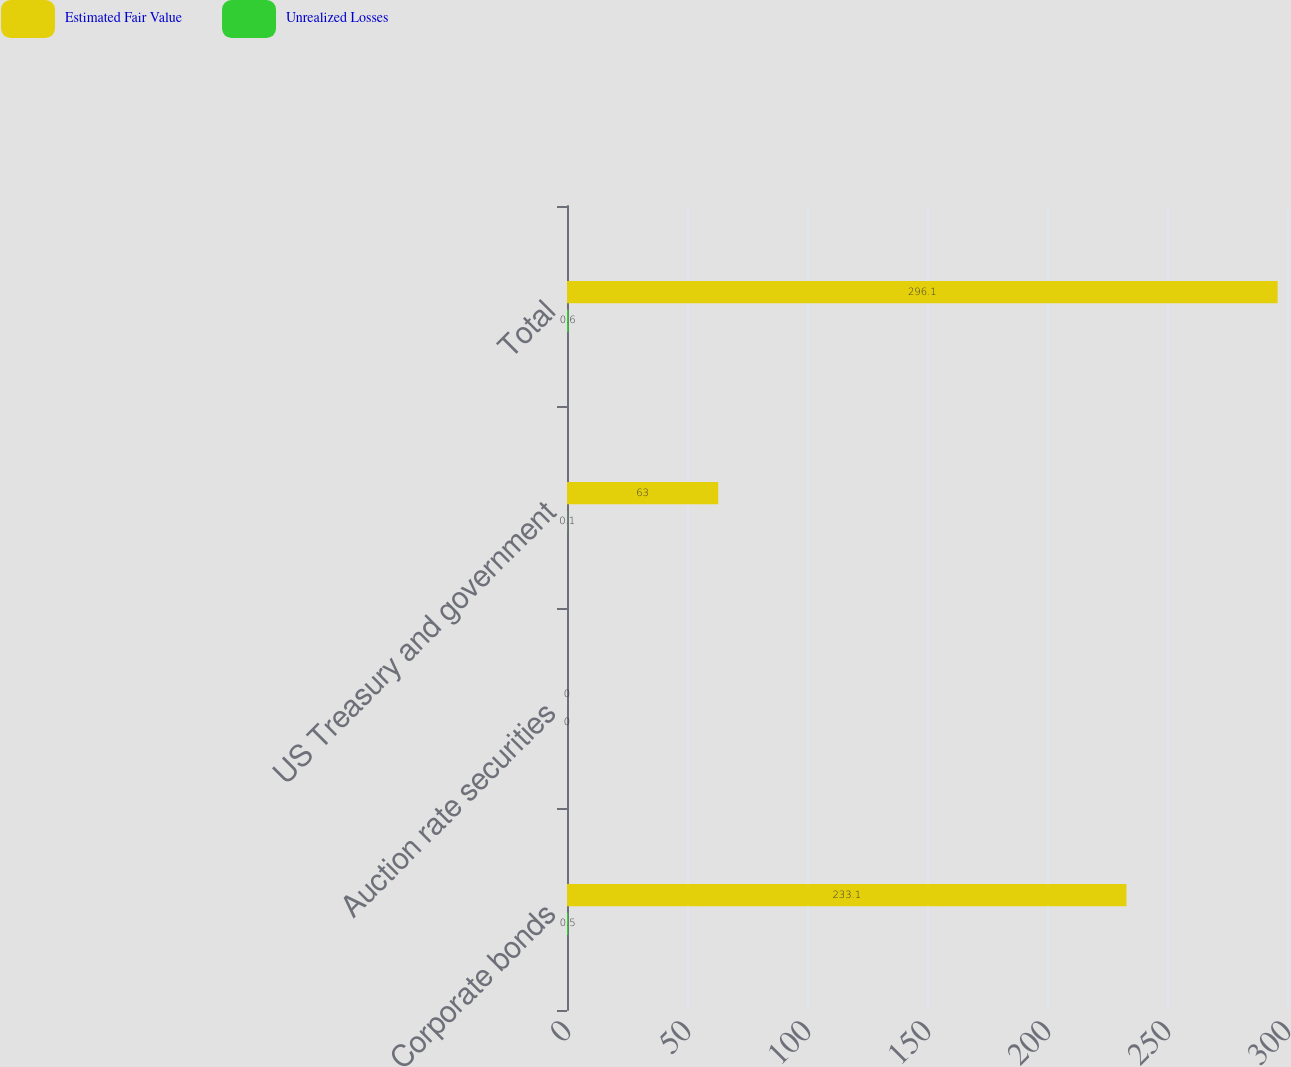Convert chart. <chart><loc_0><loc_0><loc_500><loc_500><stacked_bar_chart><ecel><fcel>Corporate bonds<fcel>Auction rate securities<fcel>US Treasury and government<fcel>Total<nl><fcel>Estimated Fair Value<fcel>233.1<fcel>0<fcel>63<fcel>296.1<nl><fcel>Unrealized Losses<fcel>0.5<fcel>0<fcel>0.1<fcel>0.6<nl></chart> 